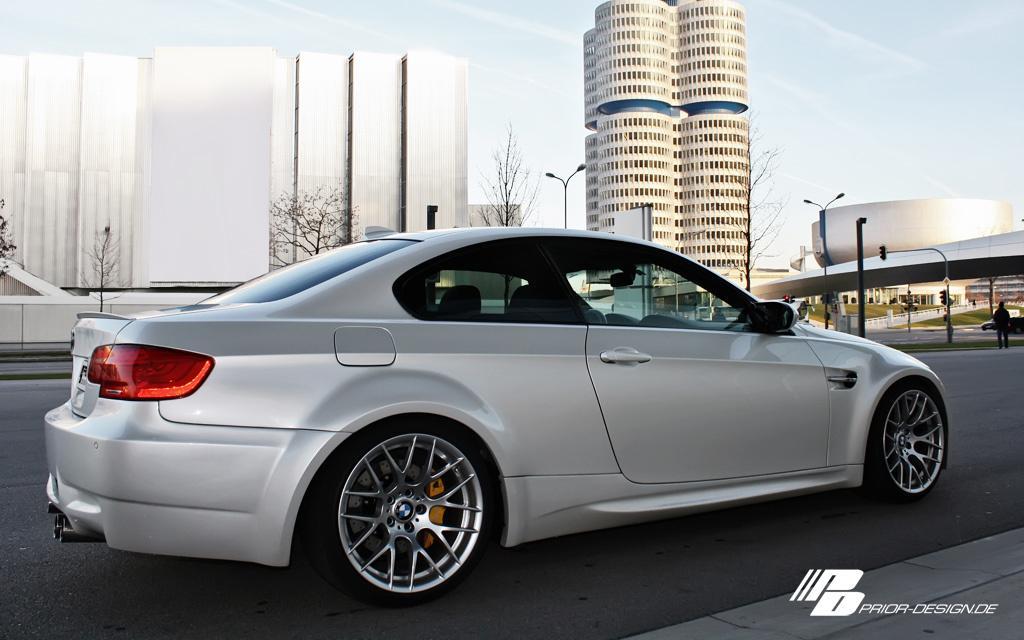Describe this image in one or two sentences. In this picture we can see a car on the road. Behind the car, there are trees, buildings, street lights and grass. On the right side of the image, there is a bridge, a pole and some objects. In the bottom right corner of the image, there is a watermark. 